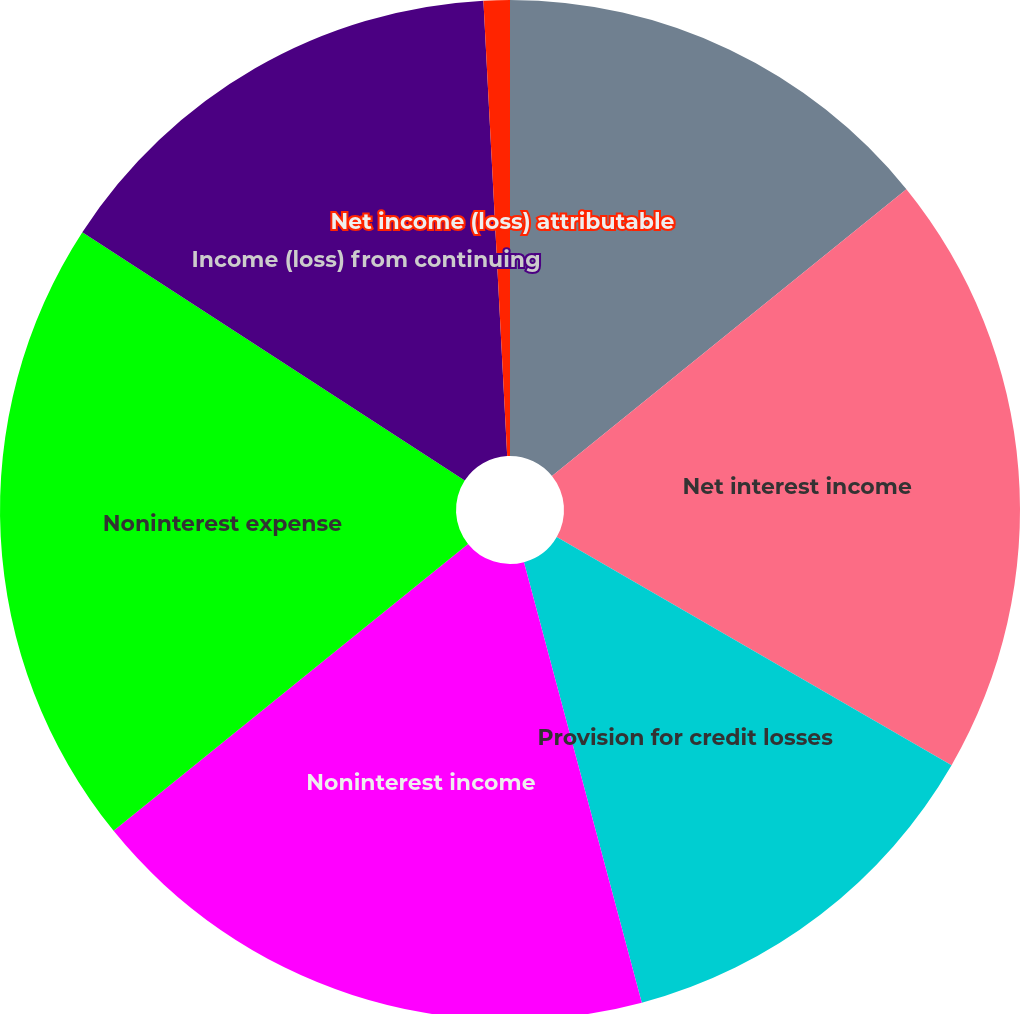<chart> <loc_0><loc_0><loc_500><loc_500><pie_chart><fcel>Interest expense<fcel>Net interest income<fcel>Provision for credit losses<fcel>Noninterest income<fcel>Noninterest expense<fcel>Income (loss) from continuing<fcel>Net income (loss) attributable<nl><fcel>14.17%<fcel>19.17%<fcel>12.5%<fcel>18.33%<fcel>20.0%<fcel>15.0%<fcel>0.83%<nl></chart> 